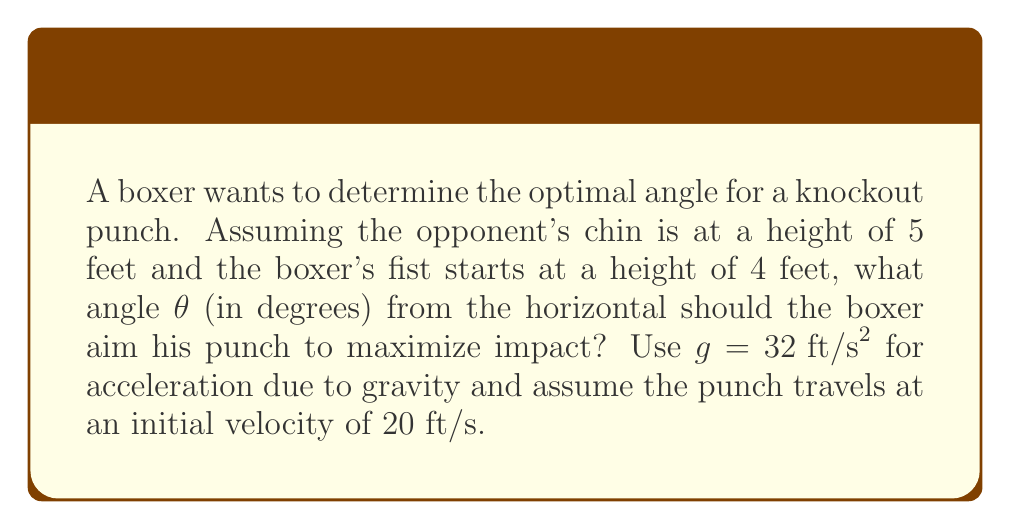Show me your answer to this math problem. To solve this problem, we'll use the principles of projectile motion in analytic geometry.

1) The trajectory of the punch can be modeled using the parametric equations:
   $$x = v_0 \cos(\theta) t$$
   $$y = 4 + v_0 \sin(\theta) t - \frac{1}{2}gt^2$$

2) We want to find θ when y = 5 (the height of the opponent's chin). The horizontal distance doesn't matter for this problem.

3) Substituting y = 5 and the given values:
   $$5 = 4 + 20 \sin(\theta) t - 16t^2$$

4) Rearranging:
   $$16t^2 - 20 \sin(\theta) t - 1 = 0$$

5) This is a quadratic in t. For maximum impact, we want the punch to reach the chin at its highest point. This occurs when there's only one solution to the quadratic, i.e., when its discriminant is zero.

6) The discriminant of $at^2 + bt + c = 0$ is $b^2 - 4ac$. Setting this to zero:
   $$(20 \sin(\theta))^2 - 4(16)(-1) = 0$$

7) Simplifying:
   $$400 \sin^2(\theta) = 64$$
   $$\sin^2(\theta) = \frac{16}{100} = 0.16$$

8) Taking the square root:
   $$\sin(\theta) = 0.4$$

9) Taking the inverse sine (arcsin):
   $$\theta = \arcsin(0.4) \approx 23.5782°$$

[asy]
import geometry;

size(200);
draw((0,0)--(10,0), arrow=Arrow);
draw((0,0)--(0,6), arrow=Arrow);
draw((0,4)--(8.8,5), arrow=Arrow);

label("0", (0,0), SW);
label("4 ft", (0,4), W);
label("5 ft", (0,5), W);
label("$\theta$", (1,4), N);
label("x", (10,0), E);
label("y", (0,6), N);
[/asy]
Answer: $23.6°$ 